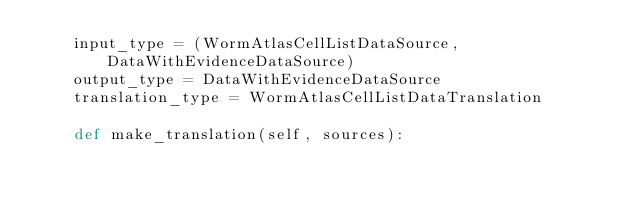Convert code to text. <code><loc_0><loc_0><loc_500><loc_500><_Python_>    input_type = (WormAtlasCellListDataSource, DataWithEvidenceDataSource)
    output_type = DataWithEvidenceDataSource
    translation_type = WormAtlasCellListDataTranslation

    def make_translation(self, sources):</code> 